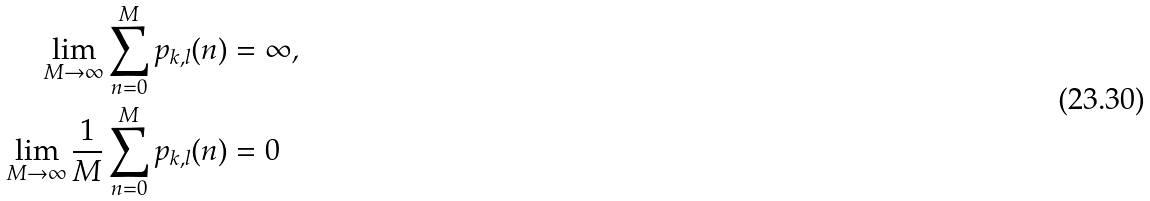Convert formula to latex. <formula><loc_0><loc_0><loc_500><loc_500>\lim _ { M \rightarrow \infty } \sum _ { n = 0 } ^ { M } p _ { k , l } ( n ) & = \infty \text {,} \\ \lim _ { M \rightarrow \infty } \frac { 1 } { M } \sum _ { n = 0 } ^ { M } p _ { k , l } ( n ) & = 0</formula> 